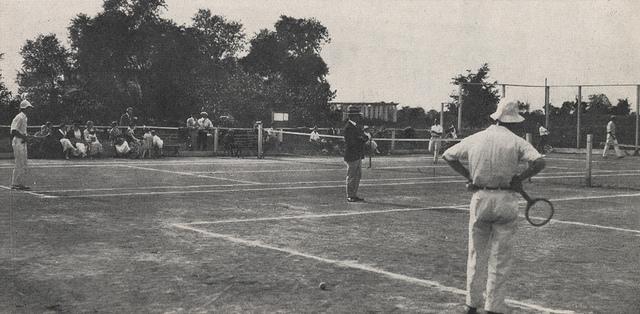What color hat are the men wearing?
Give a very brief answer. White. Was this photo taken in the 21st century?
Give a very brief answer. No. What game are the people playing?
Short answer required. Tennis. Are the men playing tennis?
Quick response, please. Yes. What type of suit is the man wearing?
Give a very brief answer. Tennis. 